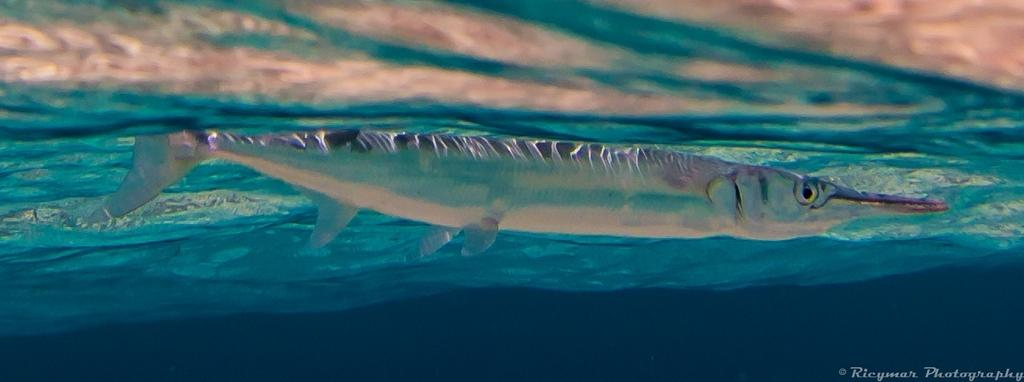What is depicted in the image? There is a picture of a fish in the image. Where is the fish located? The fish is in the water. What letter can be seen in the image? There is no letter present in the image; it features a picture of a fish in the water. Is there a cow in the image? No, there is no cow in the image; it features a picture of a fish in the water. 